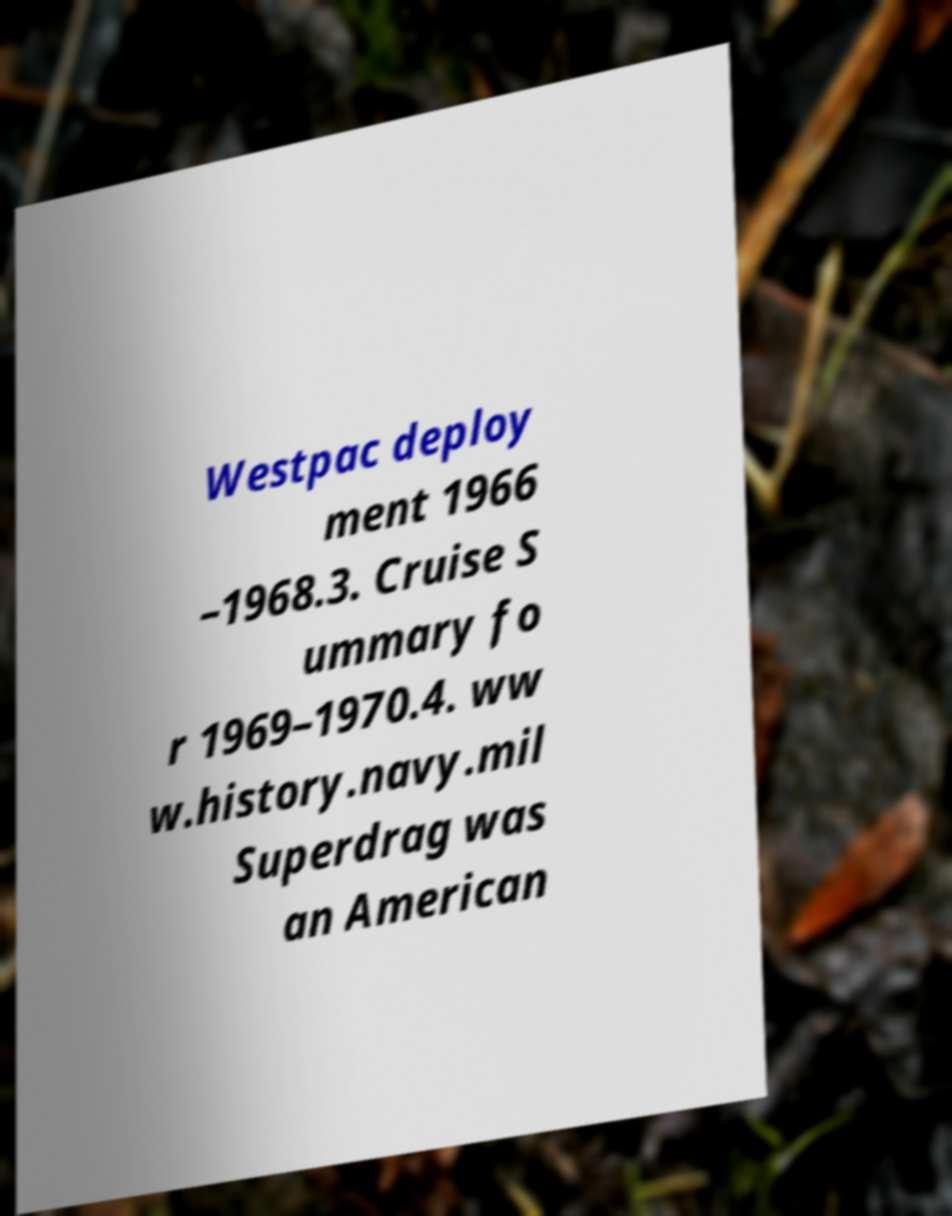There's text embedded in this image that I need extracted. Can you transcribe it verbatim? Westpac deploy ment 1966 –1968.3. Cruise S ummary fo r 1969–1970.4. ww w.history.navy.mil Superdrag was an American 